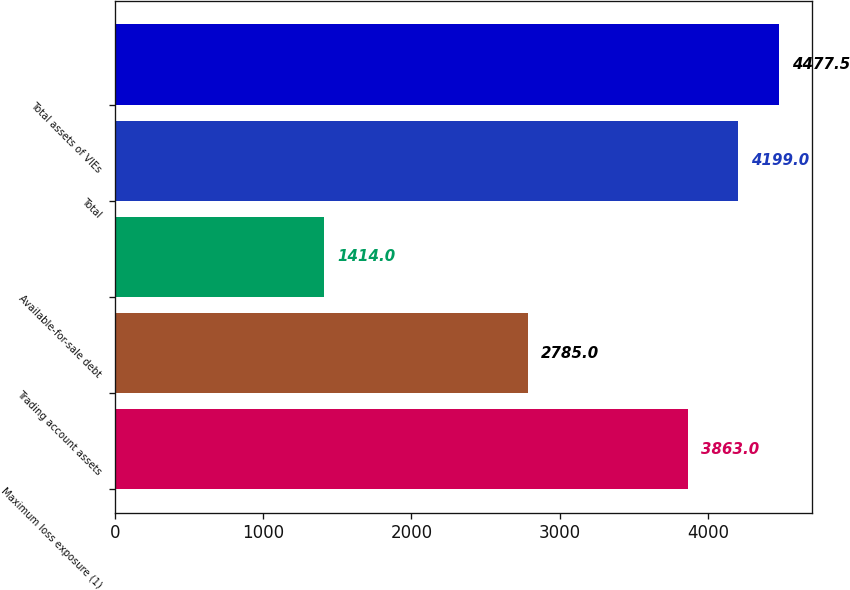<chart> <loc_0><loc_0><loc_500><loc_500><bar_chart><fcel>Maximum loss exposure (1)<fcel>Trading account assets<fcel>Available-for-sale debt<fcel>Total<fcel>Total assets of VIEs<nl><fcel>3863<fcel>2785<fcel>1414<fcel>4199<fcel>4477.5<nl></chart> 